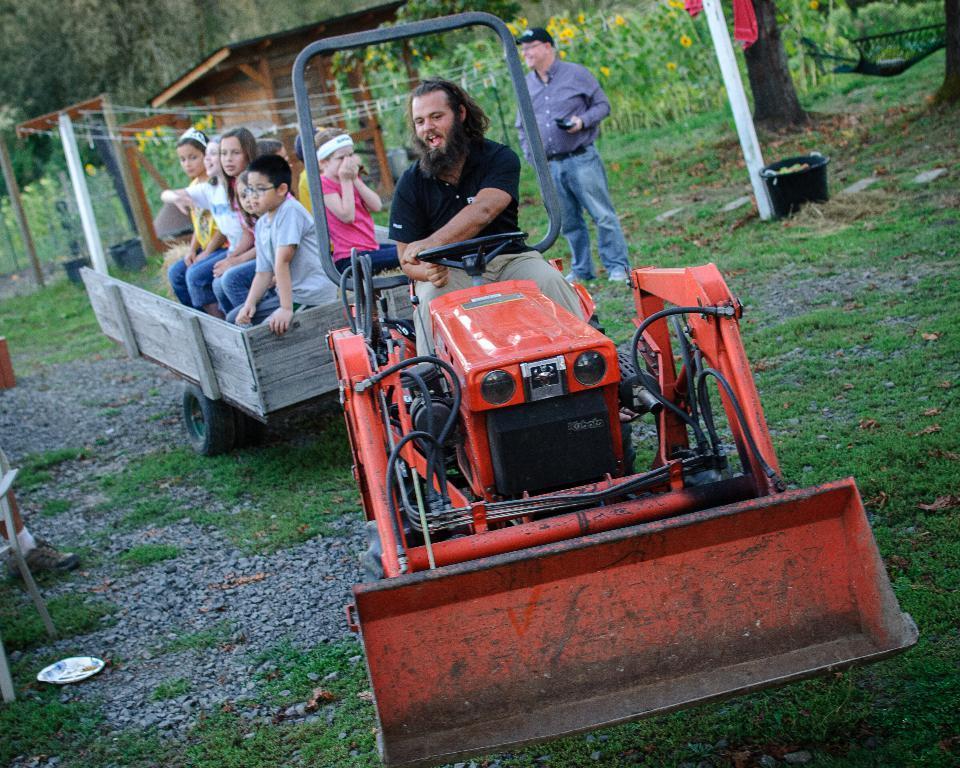Can you describe this image briefly? There are people sitting on vehicle and this man standing. We can see grass. In the background we can see trees,plants and flowers. 